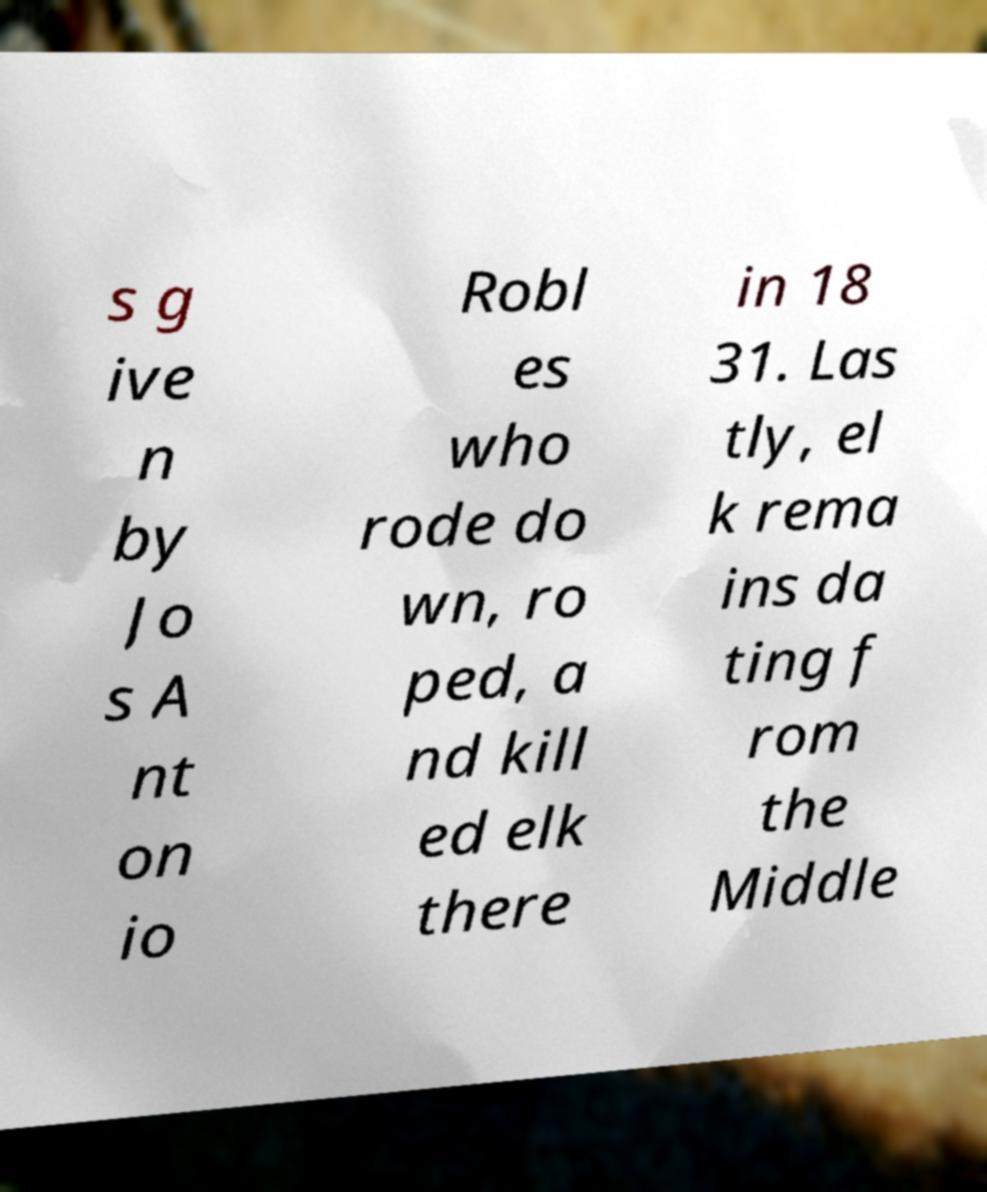There's text embedded in this image that I need extracted. Can you transcribe it verbatim? s g ive n by Jo s A nt on io Robl es who rode do wn, ro ped, a nd kill ed elk there in 18 31. Las tly, el k rema ins da ting f rom the Middle 